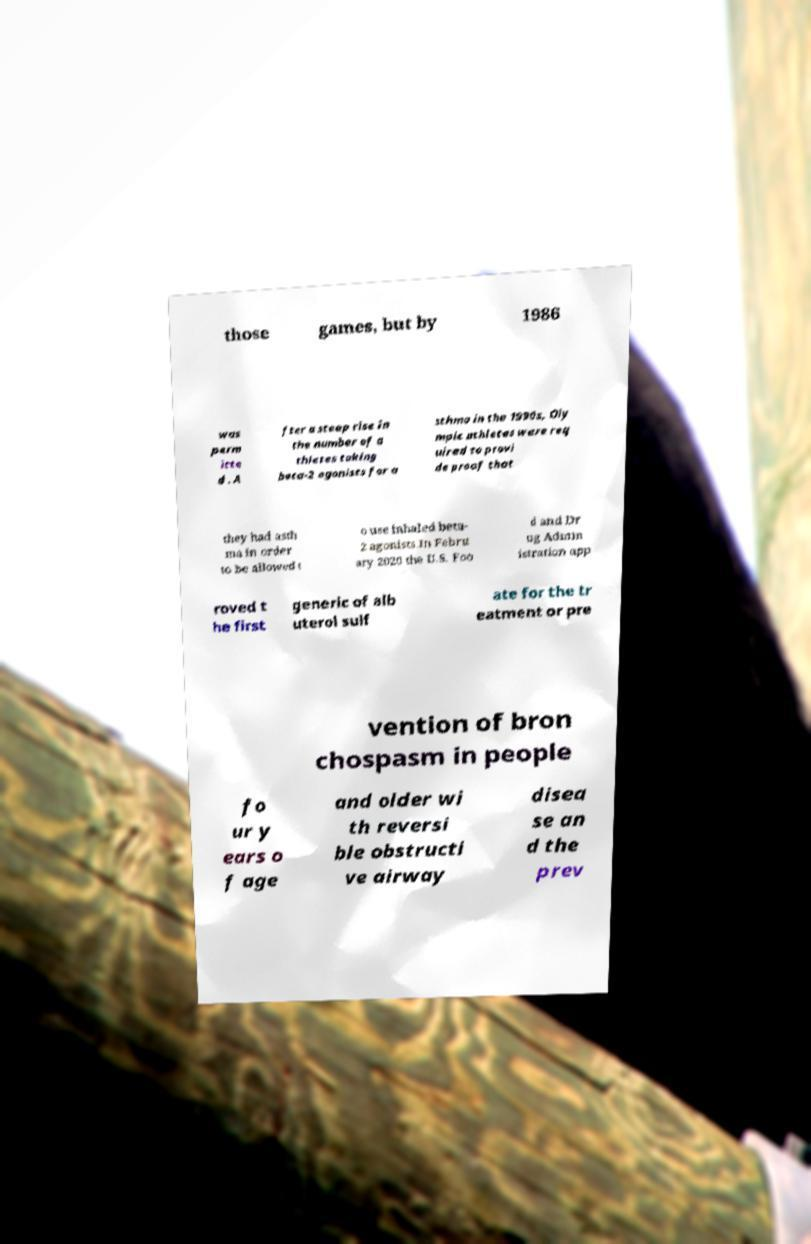Could you assist in decoding the text presented in this image and type it out clearly? those games, but by 1986 was perm itte d . A fter a steep rise in the number of a thletes taking beta-2 agonists for a sthma in the 1990s, Oly mpic athletes were req uired to provi de proof that they had asth ma in order to be allowed t o use inhaled beta- 2 agonists.In Febru ary 2020 the U.S. Foo d and Dr ug Admin istration app roved t he first generic of alb uterol sulf ate for the tr eatment or pre vention of bron chospasm in people fo ur y ears o f age and older wi th reversi ble obstructi ve airway disea se an d the prev 